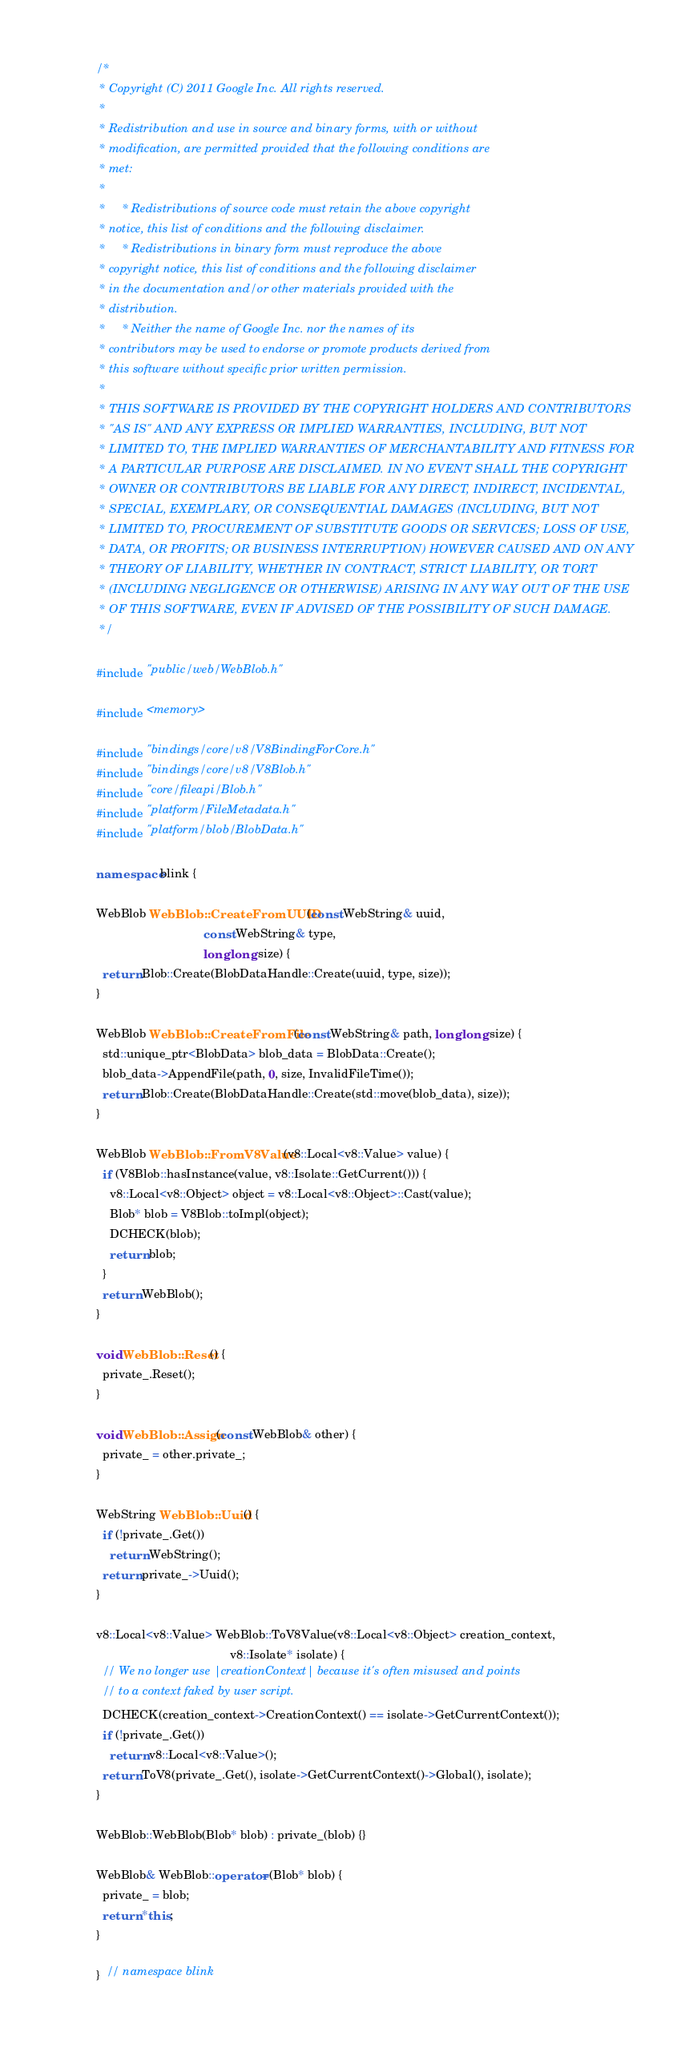Convert code to text. <code><loc_0><loc_0><loc_500><loc_500><_C++_>/*
 * Copyright (C) 2011 Google Inc. All rights reserved.
 *
 * Redistribution and use in source and binary forms, with or without
 * modification, are permitted provided that the following conditions are
 * met:
 *
 *     * Redistributions of source code must retain the above copyright
 * notice, this list of conditions and the following disclaimer.
 *     * Redistributions in binary form must reproduce the above
 * copyright notice, this list of conditions and the following disclaimer
 * in the documentation and/or other materials provided with the
 * distribution.
 *     * Neither the name of Google Inc. nor the names of its
 * contributors may be used to endorse or promote products derived from
 * this software without specific prior written permission.
 *
 * THIS SOFTWARE IS PROVIDED BY THE COPYRIGHT HOLDERS AND CONTRIBUTORS
 * "AS IS" AND ANY EXPRESS OR IMPLIED WARRANTIES, INCLUDING, BUT NOT
 * LIMITED TO, THE IMPLIED WARRANTIES OF MERCHANTABILITY AND FITNESS FOR
 * A PARTICULAR PURPOSE ARE DISCLAIMED. IN NO EVENT SHALL THE COPYRIGHT
 * OWNER OR CONTRIBUTORS BE LIABLE FOR ANY DIRECT, INDIRECT, INCIDENTAL,
 * SPECIAL, EXEMPLARY, OR CONSEQUENTIAL DAMAGES (INCLUDING, BUT NOT
 * LIMITED TO, PROCUREMENT OF SUBSTITUTE GOODS OR SERVICES; LOSS OF USE,
 * DATA, OR PROFITS; OR BUSINESS INTERRUPTION) HOWEVER CAUSED AND ON ANY
 * THEORY OF LIABILITY, WHETHER IN CONTRACT, STRICT LIABILITY, OR TORT
 * (INCLUDING NEGLIGENCE OR OTHERWISE) ARISING IN ANY WAY OUT OF THE USE
 * OF THIS SOFTWARE, EVEN IF ADVISED OF THE POSSIBILITY OF SUCH DAMAGE.
 */

#include "public/web/WebBlob.h"

#include <memory>

#include "bindings/core/v8/V8BindingForCore.h"
#include "bindings/core/v8/V8Blob.h"
#include "core/fileapi/Blob.h"
#include "platform/FileMetadata.h"
#include "platform/blob/BlobData.h"

namespace blink {

WebBlob WebBlob::CreateFromUUID(const WebString& uuid,
                                const WebString& type,
                                long long size) {
  return Blob::Create(BlobDataHandle::Create(uuid, type, size));
}

WebBlob WebBlob::CreateFromFile(const WebString& path, long long size) {
  std::unique_ptr<BlobData> blob_data = BlobData::Create();
  blob_data->AppendFile(path, 0, size, InvalidFileTime());
  return Blob::Create(BlobDataHandle::Create(std::move(blob_data), size));
}

WebBlob WebBlob::FromV8Value(v8::Local<v8::Value> value) {
  if (V8Blob::hasInstance(value, v8::Isolate::GetCurrent())) {
    v8::Local<v8::Object> object = v8::Local<v8::Object>::Cast(value);
    Blob* blob = V8Blob::toImpl(object);
    DCHECK(blob);
    return blob;
  }
  return WebBlob();
}

void WebBlob::Reset() {
  private_.Reset();
}

void WebBlob::Assign(const WebBlob& other) {
  private_ = other.private_;
}

WebString WebBlob::Uuid() {
  if (!private_.Get())
    return WebString();
  return private_->Uuid();
}

v8::Local<v8::Value> WebBlob::ToV8Value(v8::Local<v8::Object> creation_context,
                                        v8::Isolate* isolate) {
  // We no longer use |creationContext| because it's often misused and points
  // to a context faked by user script.
  DCHECK(creation_context->CreationContext() == isolate->GetCurrentContext());
  if (!private_.Get())
    return v8::Local<v8::Value>();
  return ToV8(private_.Get(), isolate->GetCurrentContext()->Global(), isolate);
}

WebBlob::WebBlob(Blob* blob) : private_(blob) {}

WebBlob& WebBlob::operator=(Blob* blob) {
  private_ = blob;
  return *this;
}

}  // namespace blink
</code> 